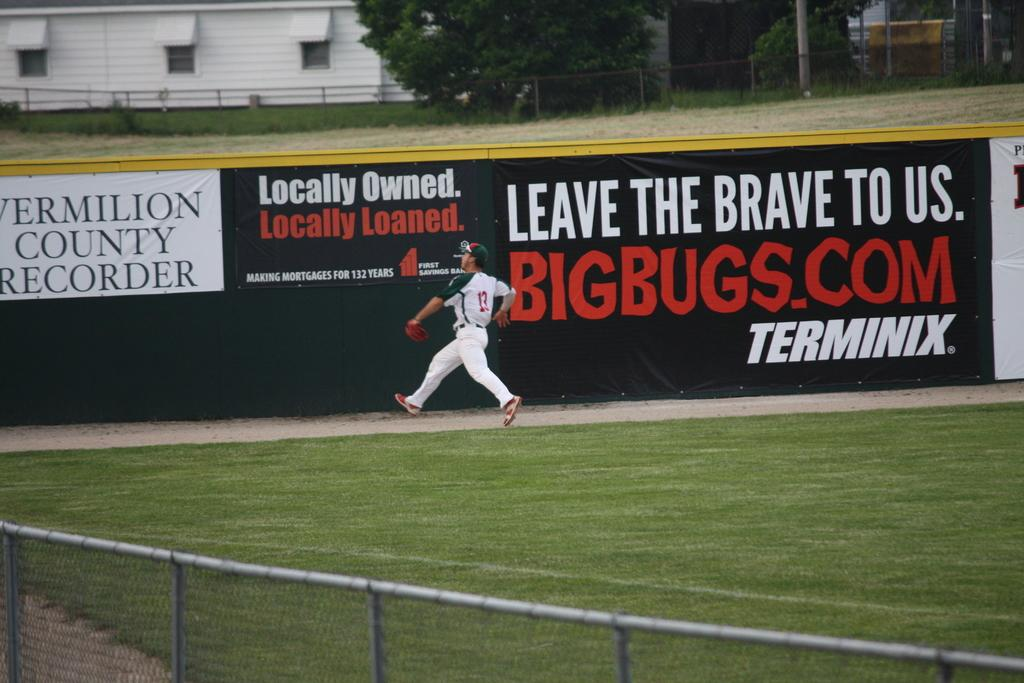Provide a one-sentence caption for the provided image. Baseball player wearing number 13 going for the ball. 